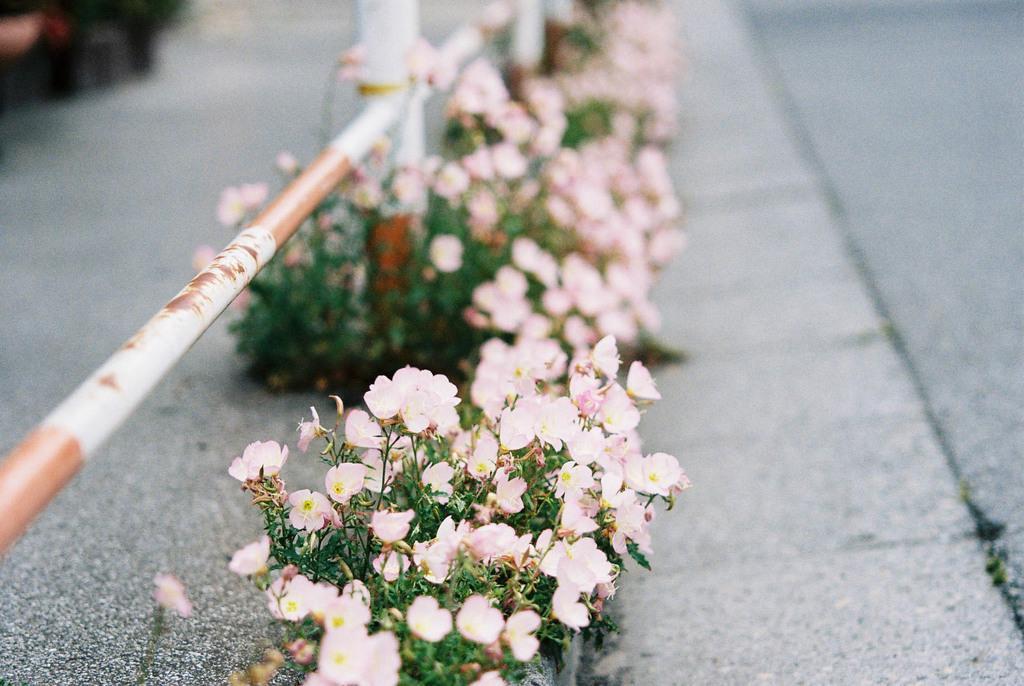Please provide a concise description of this image. These are the small plants with small flowers, which are light pink in color. This looks like an iron pole. I think this is the road. 